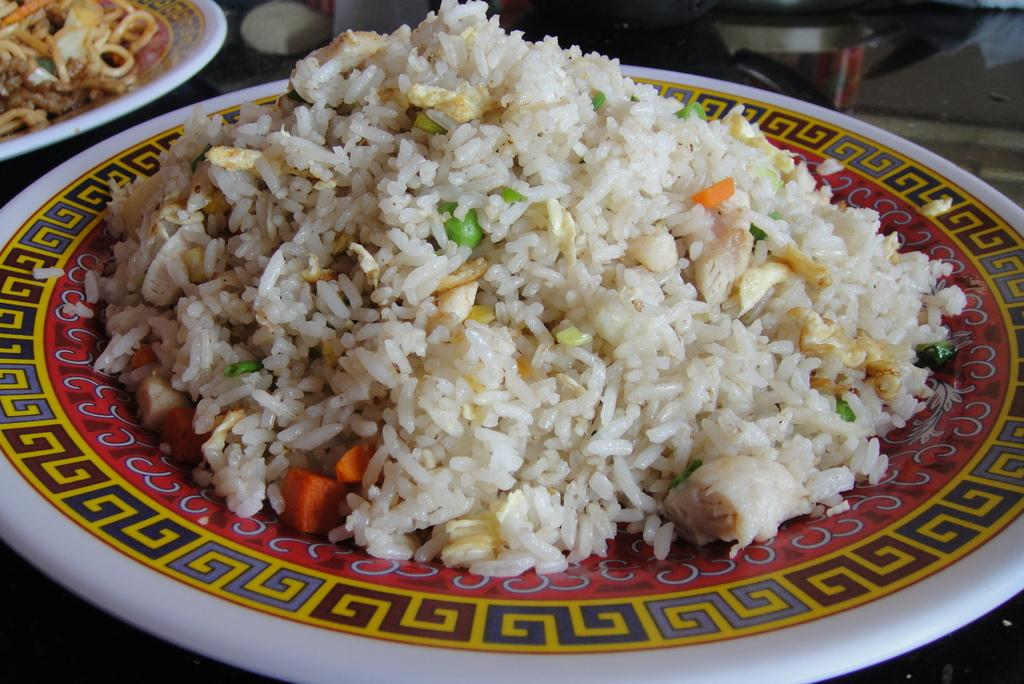What objects are present in the image that are typically used for serving food? There are plates in the image. Where are the plates located? The plates are on an object. What can be found on top of the plates? There are food items on the plates. What type of ticket is visible on the plate in the image? There is no ticket present on the plate in the image. What is the condition of the yam on the plate in the image? There is no yam present on the plate in the image. 